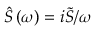Convert formula to latex. <formula><loc_0><loc_0><loc_500><loc_500>\hat { S } \left ( \omega \right ) = i \tilde { S } / \omega</formula> 